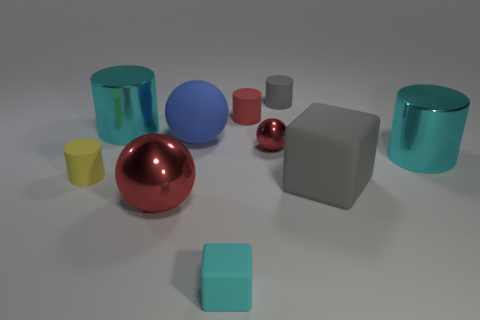Subtract all small cylinders. How many cylinders are left? 2 Subtract 2 blocks. How many blocks are left? 0 Subtract all blue spheres. How many spheres are left? 2 Subtract all balls. How many objects are left? 7 Subtract all brown blocks. How many cyan cylinders are left? 2 Subtract all small green shiny things. Subtract all blue objects. How many objects are left? 9 Add 4 small yellow rubber cylinders. How many small yellow rubber cylinders are left? 5 Add 7 yellow cylinders. How many yellow cylinders exist? 8 Subtract 1 red spheres. How many objects are left? 9 Subtract all brown spheres. Subtract all cyan cylinders. How many spheres are left? 3 